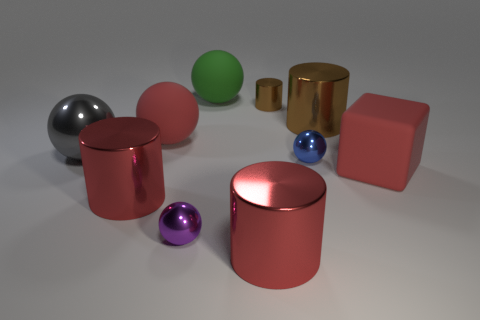What color is the large metallic cylinder right of the large red cylinder that is to the right of the large green rubber object?
Your response must be concise. Brown. What size is the object that is the same color as the small cylinder?
Offer a terse response. Large. How many red cubes are left of the red thing right of the big cylinder behind the big red matte sphere?
Provide a short and direct response. 0. Is the shape of the large brown object on the right side of the tiny shiny cylinder the same as the red rubber object that is to the left of the tiny purple sphere?
Your answer should be very brief. No. How many things are either tiny spheres or green rubber balls?
Keep it short and to the point. 3. There is a sphere that is in front of the big red matte object on the right side of the purple shiny object; what is it made of?
Ensure brevity in your answer.  Metal. Is there another metallic sphere that has the same color as the big metal sphere?
Your response must be concise. No. What is the color of the other sphere that is the same size as the blue metal ball?
Give a very brief answer. Purple. What material is the big cylinder behind the big matte thing on the right side of the red cylinder to the right of the green rubber ball?
Your answer should be compact. Metal. Do the tiny cylinder and the large cube on the right side of the tiny brown shiny thing have the same color?
Offer a very short reply. No. 